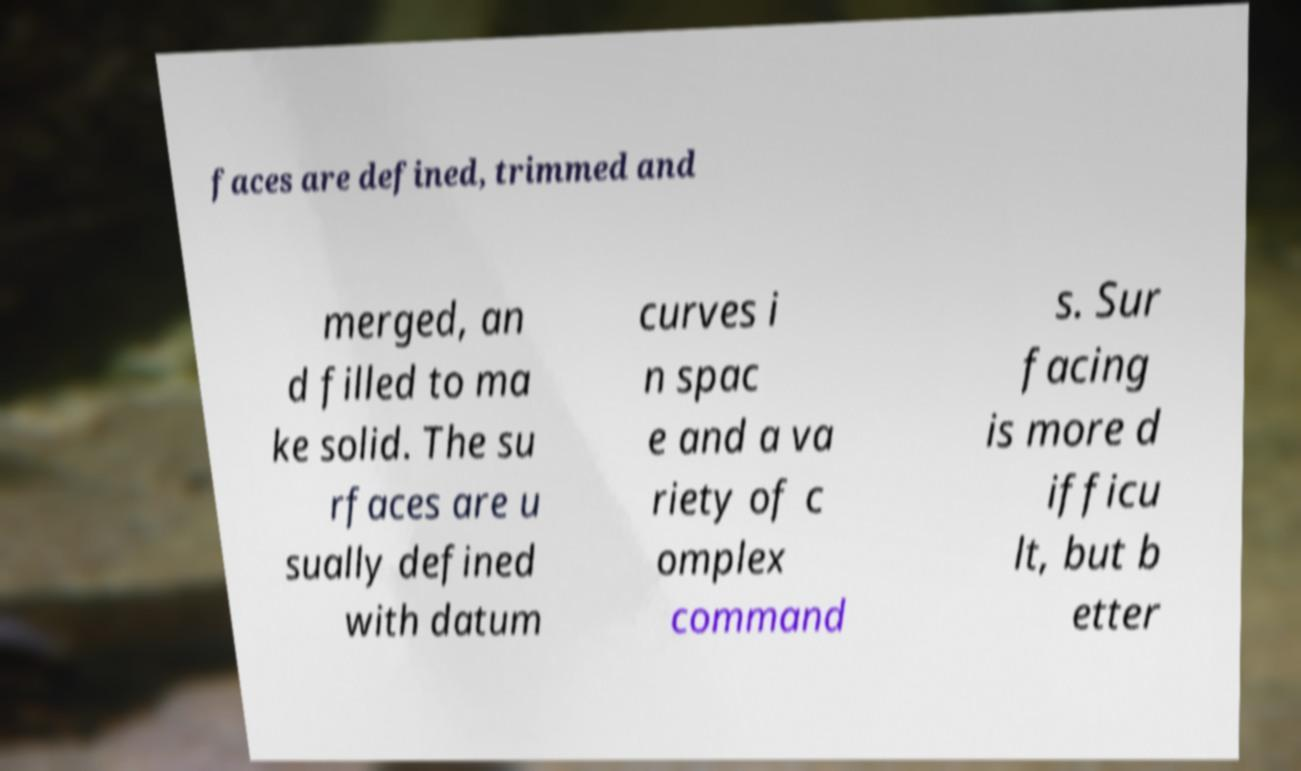Can you read and provide the text displayed in the image?This photo seems to have some interesting text. Can you extract and type it out for me? faces are defined, trimmed and merged, an d filled to ma ke solid. The su rfaces are u sually defined with datum curves i n spac e and a va riety of c omplex command s. Sur facing is more d ifficu lt, but b etter 